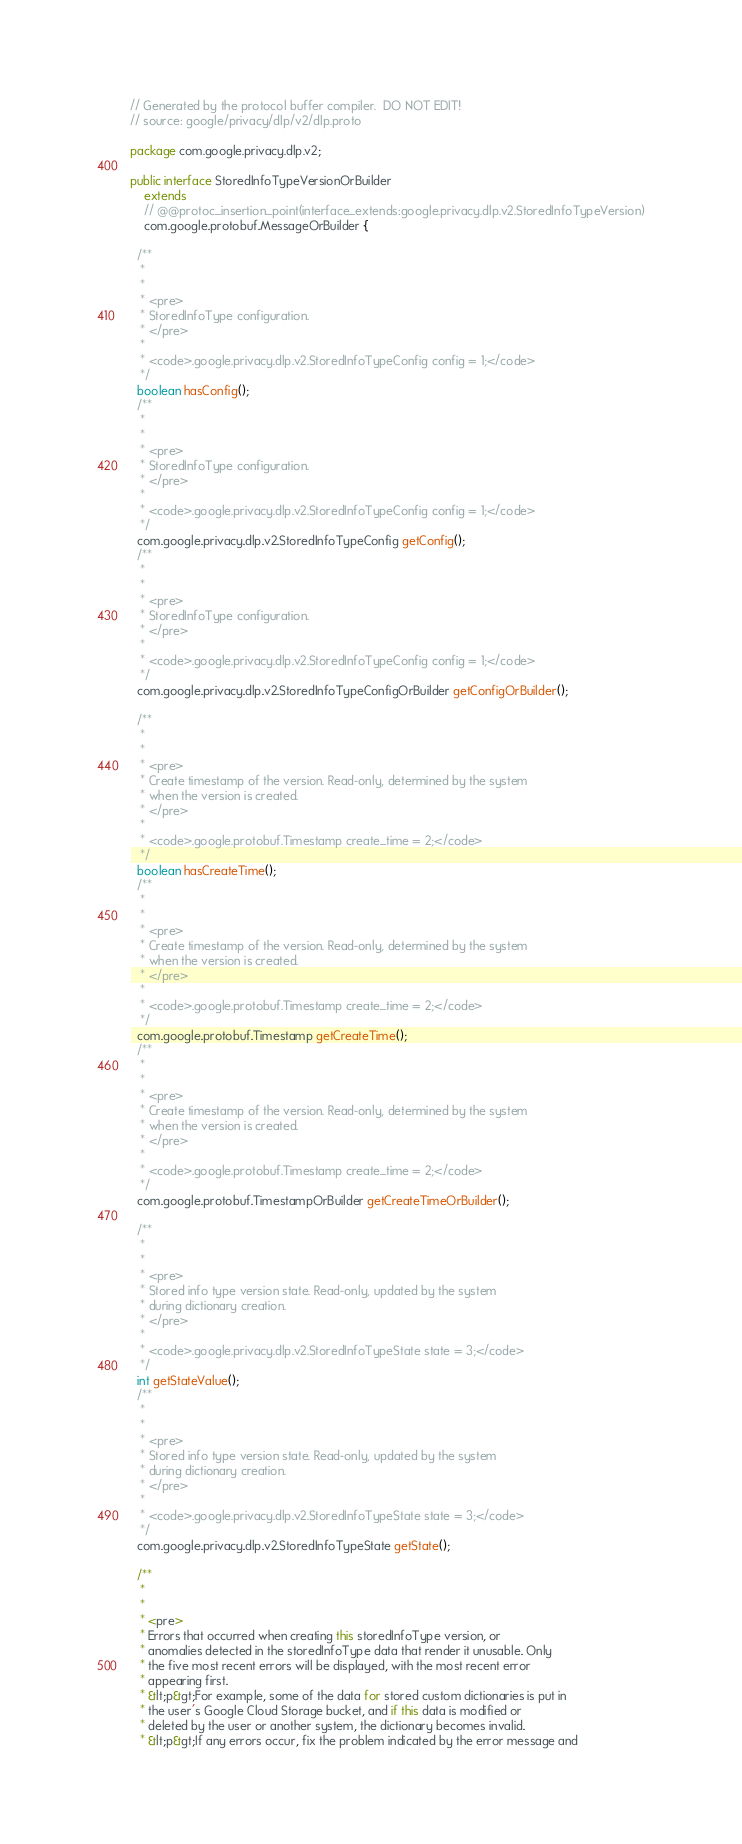<code> <loc_0><loc_0><loc_500><loc_500><_Java_>// Generated by the protocol buffer compiler.  DO NOT EDIT!
// source: google/privacy/dlp/v2/dlp.proto

package com.google.privacy.dlp.v2;

public interface StoredInfoTypeVersionOrBuilder
    extends
    // @@protoc_insertion_point(interface_extends:google.privacy.dlp.v2.StoredInfoTypeVersion)
    com.google.protobuf.MessageOrBuilder {

  /**
   *
   *
   * <pre>
   * StoredInfoType configuration.
   * </pre>
   *
   * <code>.google.privacy.dlp.v2.StoredInfoTypeConfig config = 1;</code>
   */
  boolean hasConfig();
  /**
   *
   *
   * <pre>
   * StoredInfoType configuration.
   * </pre>
   *
   * <code>.google.privacy.dlp.v2.StoredInfoTypeConfig config = 1;</code>
   */
  com.google.privacy.dlp.v2.StoredInfoTypeConfig getConfig();
  /**
   *
   *
   * <pre>
   * StoredInfoType configuration.
   * </pre>
   *
   * <code>.google.privacy.dlp.v2.StoredInfoTypeConfig config = 1;</code>
   */
  com.google.privacy.dlp.v2.StoredInfoTypeConfigOrBuilder getConfigOrBuilder();

  /**
   *
   *
   * <pre>
   * Create timestamp of the version. Read-only, determined by the system
   * when the version is created.
   * </pre>
   *
   * <code>.google.protobuf.Timestamp create_time = 2;</code>
   */
  boolean hasCreateTime();
  /**
   *
   *
   * <pre>
   * Create timestamp of the version. Read-only, determined by the system
   * when the version is created.
   * </pre>
   *
   * <code>.google.protobuf.Timestamp create_time = 2;</code>
   */
  com.google.protobuf.Timestamp getCreateTime();
  /**
   *
   *
   * <pre>
   * Create timestamp of the version. Read-only, determined by the system
   * when the version is created.
   * </pre>
   *
   * <code>.google.protobuf.Timestamp create_time = 2;</code>
   */
  com.google.protobuf.TimestampOrBuilder getCreateTimeOrBuilder();

  /**
   *
   *
   * <pre>
   * Stored info type version state. Read-only, updated by the system
   * during dictionary creation.
   * </pre>
   *
   * <code>.google.privacy.dlp.v2.StoredInfoTypeState state = 3;</code>
   */
  int getStateValue();
  /**
   *
   *
   * <pre>
   * Stored info type version state. Read-only, updated by the system
   * during dictionary creation.
   * </pre>
   *
   * <code>.google.privacy.dlp.v2.StoredInfoTypeState state = 3;</code>
   */
  com.google.privacy.dlp.v2.StoredInfoTypeState getState();

  /**
   *
   *
   * <pre>
   * Errors that occurred when creating this storedInfoType version, or
   * anomalies detected in the storedInfoType data that render it unusable. Only
   * the five most recent errors will be displayed, with the most recent error
   * appearing first.
   * &lt;p&gt;For example, some of the data for stored custom dictionaries is put in
   * the user's Google Cloud Storage bucket, and if this data is modified or
   * deleted by the user or another system, the dictionary becomes invalid.
   * &lt;p&gt;If any errors occur, fix the problem indicated by the error message and</code> 